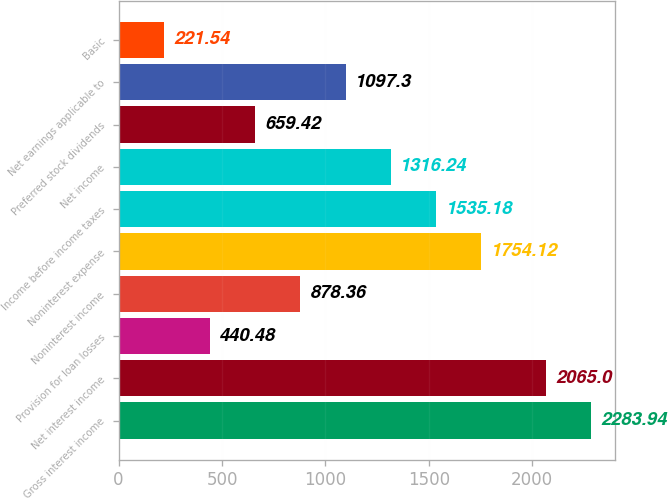Convert chart to OTSL. <chart><loc_0><loc_0><loc_500><loc_500><bar_chart><fcel>Gross interest income<fcel>Net interest income<fcel>Provision for loan losses<fcel>Noninterest income<fcel>Noninterest expense<fcel>Income before income taxes<fcel>Net income<fcel>Preferred stock dividends<fcel>Net earnings applicable to<fcel>Basic<nl><fcel>2283.94<fcel>2065<fcel>440.48<fcel>878.36<fcel>1754.12<fcel>1535.18<fcel>1316.24<fcel>659.42<fcel>1097.3<fcel>221.54<nl></chart> 